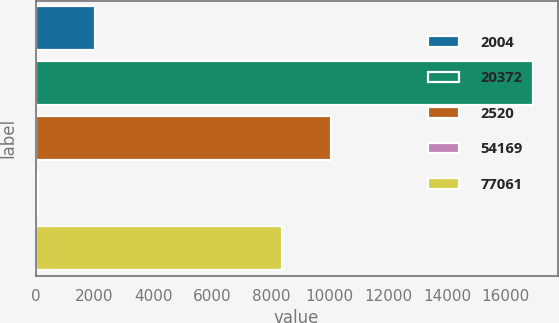Convert chart. <chart><loc_0><loc_0><loc_500><loc_500><bar_chart><fcel>2004<fcel>20372<fcel>2520<fcel>54169<fcel>77061<nl><fcel>2003<fcel>16914<fcel>10058.4<fcel>80<fcel>8375<nl></chart> 